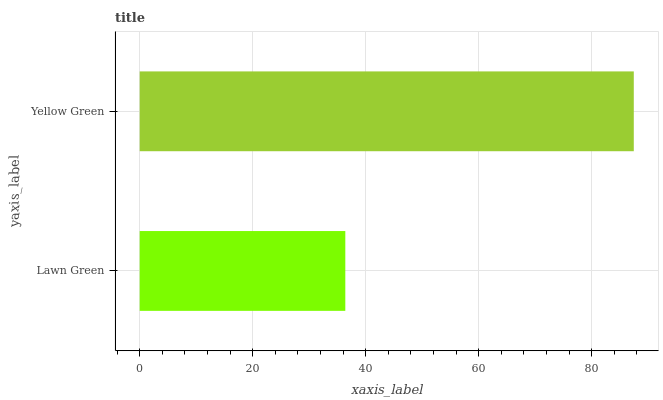Is Lawn Green the minimum?
Answer yes or no. Yes. Is Yellow Green the maximum?
Answer yes or no. Yes. Is Yellow Green the minimum?
Answer yes or no. No. Is Yellow Green greater than Lawn Green?
Answer yes or no. Yes. Is Lawn Green less than Yellow Green?
Answer yes or no. Yes. Is Lawn Green greater than Yellow Green?
Answer yes or no. No. Is Yellow Green less than Lawn Green?
Answer yes or no. No. Is Yellow Green the high median?
Answer yes or no. Yes. Is Lawn Green the low median?
Answer yes or no. Yes. Is Lawn Green the high median?
Answer yes or no. No. Is Yellow Green the low median?
Answer yes or no. No. 